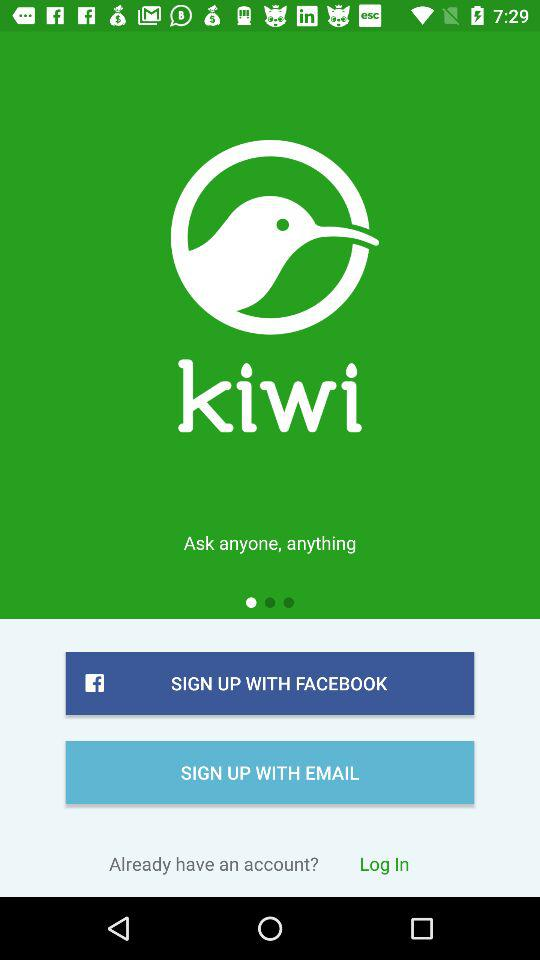Through what application can we sign up? You can sign up through "FACEBOOK". 